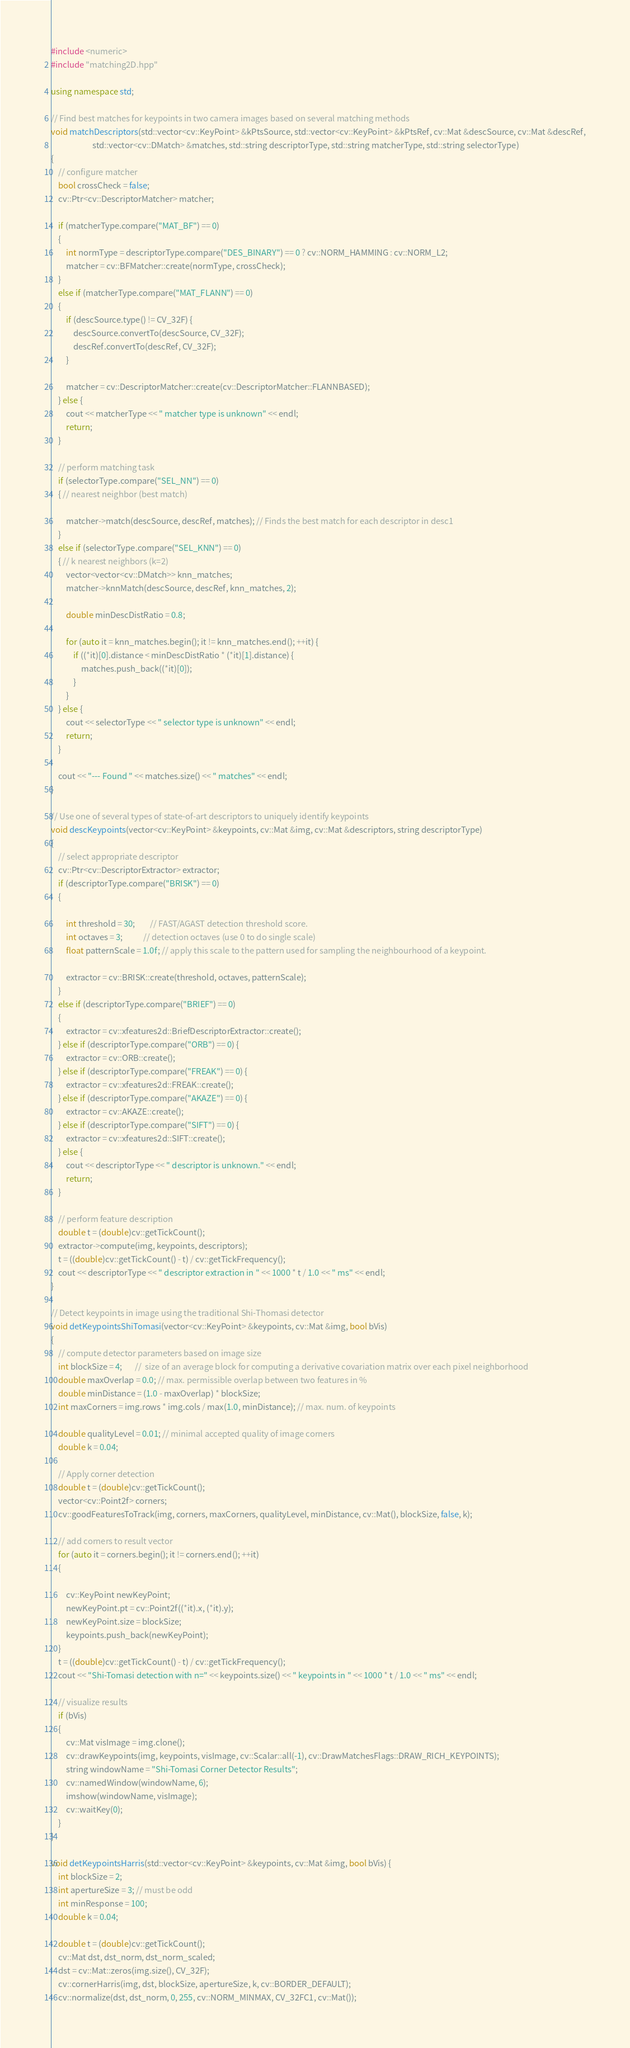<code> <loc_0><loc_0><loc_500><loc_500><_C++_>#include <numeric>
#include "matching2D.hpp"

using namespace std;

// Find best matches for keypoints in two camera images based on several matching methods
void matchDescriptors(std::vector<cv::KeyPoint> &kPtsSource, std::vector<cv::KeyPoint> &kPtsRef, cv::Mat &descSource, cv::Mat &descRef,
                      std::vector<cv::DMatch> &matches, std::string descriptorType, std::string matcherType, std::string selectorType)
{
    // configure matcher
    bool crossCheck = false;
    cv::Ptr<cv::DescriptorMatcher> matcher;

    if (matcherType.compare("MAT_BF") == 0)
    {
        int normType = descriptorType.compare("DES_BINARY") == 0 ? cv::NORM_HAMMING : cv::NORM_L2;
        matcher = cv::BFMatcher::create(normType, crossCheck);
    }
    else if (matcherType.compare("MAT_FLANN") == 0)
    {
        if (descSource.type() != CV_32F) {
            descSource.convertTo(descSource, CV_32F);
            descRef.convertTo(descRef, CV_32F);
        }

        matcher = cv::DescriptorMatcher::create(cv::DescriptorMatcher::FLANNBASED);
    } else {
        cout << matcherType << " matcher type is unknown" << endl;
        return;
    }

    // perform matching task
    if (selectorType.compare("SEL_NN") == 0)
    { // nearest neighbor (best match)

        matcher->match(descSource, descRef, matches); // Finds the best match for each descriptor in desc1
    }
    else if (selectorType.compare("SEL_KNN") == 0)
    { // k nearest neighbors (k=2)
        vector<vector<cv::DMatch>> knn_matches;
        matcher->knnMatch(descSource, descRef, knn_matches, 2);

        double minDescDistRatio = 0.8;

        for (auto it = knn_matches.begin(); it != knn_matches.end(); ++it) {
            if ((*it)[0].distance < minDescDistRatio * (*it)[1].distance) {
                matches.push_back((*it)[0]);
            }
        }
    } else {
        cout << selectorType << " selector type is unknown" << endl;
        return;
    }

    cout << "--- Found " << matches.size() << " matches" << endl;
}

// Use one of several types of state-of-art descriptors to uniquely identify keypoints
void descKeypoints(vector<cv::KeyPoint> &keypoints, cv::Mat &img, cv::Mat &descriptors, string descriptorType)
{
    // select appropriate descriptor
    cv::Ptr<cv::DescriptorExtractor> extractor;
    if (descriptorType.compare("BRISK") == 0)
    {

        int threshold = 30;        // FAST/AGAST detection threshold score.
        int octaves = 3;           // detection octaves (use 0 to do single scale)
        float patternScale = 1.0f; // apply this scale to the pattern used for sampling the neighbourhood of a keypoint.

        extractor = cv::BRISK::create(threshold, octaves, patternScale);
    }
    else if (descriptorType.compare("BRIEF") == 0)
    {
        extractor = cv::xfeatures2d::BriefDescriptorExtractor::create();
    } else if (descriptorType.compare("ORB") == 0) {
        extractor = cv::ORB::create();
    } else if (descriptorType.compare("FREAK") == 0) {
        extractor = cv::xfeatures2d::FREAK::create();
    } else if (descriptorType.compare("AKAZE") == 0) {
        extractor = cv::AKAZE::create();
    } else if (descriptorType.compare("SIFT") == 0) {
        extractor = cv::xfeatures2d::SIFT::create();
    } else {
        cout << descriptorType << " descriptor is unknown." << endl;
        return;
    }

    // perform feature description
    double t = (double)cv::getTickCount();
    extractor->compute(img, keypoints, descriptors);
    t = ((double)cv::getTickCount() - t) / cv::getTickFrequency();
    cout << descriptorType << " descriptor extraction in " << 1000 * t / 1.0 << " ms" << endl;
}

// Detect keypoints in image using the traditional Shi-Thomasi detector
void detKeypointsShiTomasi(vector<cv::KeyPoint> &keypoints, cv::Mat &img, bool bVis)
{
    // compute detector parameters based on image size
    int blockSize = 4;       //  size of an average block for computing a derivative covariation matrix over each pixel neighborhood
    double maxOverlap = 0.0; // max. permissible overlap between two features in %
    double minDistance = (1.0 - maxOverlap) * blockSize;
    int maxCorners = img.rows * img.cols / max(1.0, minDistance); // max. num. of keypoints

    double qualityLevel = 0.01; // minimal accepted quality of image corners
    double k = 0.04;

    // Apply corner detection
    double t = (double)cv::getTickCount();
    vector<cv::Point2f> corners;
    cv::goodFeaturesToTrack(img, corners, maxCorners, qualityLevel, minDistance, cv::Mat(), blockSize, false, k);

    // add corners to result vector
    for (auto it = corners.begin(); it != corners.end(); ++it)
    {

        cv::KeyPoint newKeyPoint;
        newKeyPoint.pt = cv::Point2f((*it).x, (*it).y);
        newKeyPoint.size = blockSize;
        keypoints.push_back(newKeyPoint);
    }
    t = ((double)cv::getTickCount() - t) / cv::getTickFrequency();
    cout << "Shi-Tomasi detection with n=" << keypoints.size() << " keypoints in " << 1000 * t / 1.0 << " ms" << endl;

    // visualize results
    if (bVis)
    {
        cv::Mat visImage = img.clone();
        cv::drawKeypoints(img, keypoints, visImage, cv::Scalar::all(-1), cv::DrawMatchesFlags::DRAW_RICH_KEYPOINTS);
        string windowName = "Shi-Tomasi Corner Detector Results";
        cv::namedWindow(windowName, 6);
        imshow(windowName, visImage);
        cv::waitKey(0);
    }
}

void detKeypointsHarris(std::vector<cv::KeyPoint> &keypoints, cv::Mat &img, bool bVis) {
    int blockSize = 2;
    int apertureSize = 3; // must be odd
    int minResponse = 100;
    double k = 0.04;

    double t = (double)cv::getTickCount();
    cv::Mat dst, dst_norm, dst_norm_scaled;
    dst = cv::Mat::zeros(img.size(), CV_32F);
    cv::cornerHarris(img, dst, blockSize, apertureSize, k, cv::BORDER_DEFAULT);
    cv::normalize(dst, dst_norm, 0, 255, cv::NORM_MINMAX, CV_32FC1, cv::Mat());</code> 